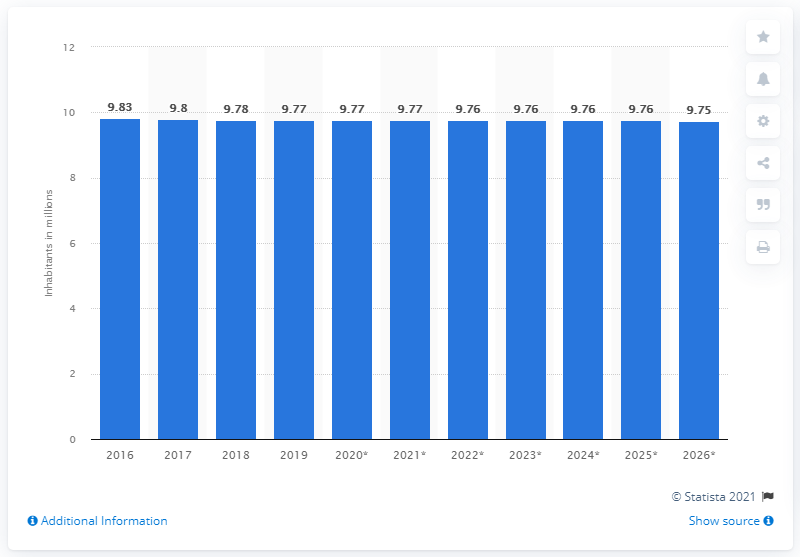Point out several critical features in this image. In 2019, the population of Hungary was approximately 9.75 million. 